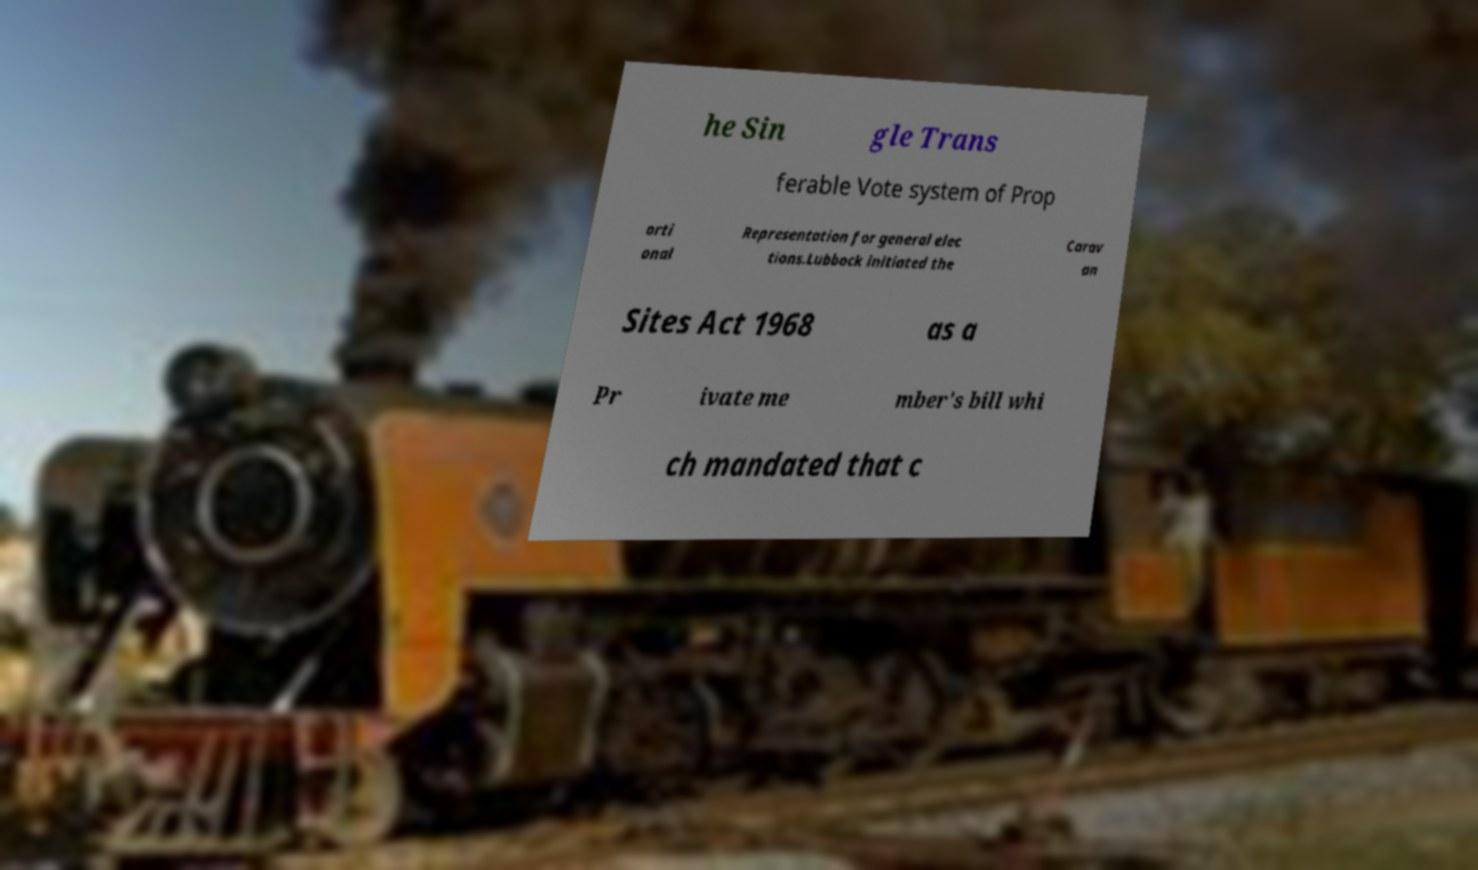There's text embedded in this image that I need extracted. Can you transcribe it verbatim? he Sin gle Trans ferable Vote system of Prop orti onal Representation for general elec tions.Lubbock initiated the Carav an Sites Act 1968 as a Pr ivate me mber's bill whi ch mandated that c 